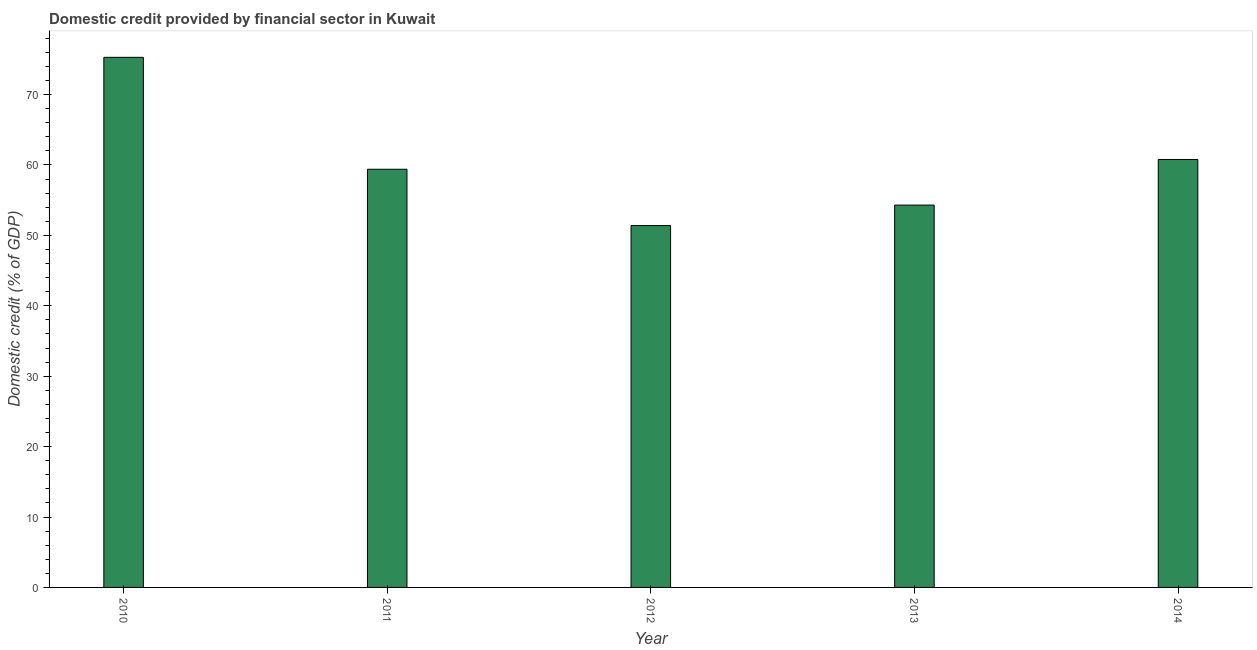What is the title of the graph?
Ensure brevity in your answer.  Domestic credit provided by financial sector in Kuwait. What is the label or title of the Y-axis?
Your answer should be very brief. Domestic credit (% of GDP). What is the domestic credit provided by financial sector in 2011?
Provide a short and direct response. 59.39. Across all years, what is the maximum domestic credit provided by financial sector?
Keep it short and to the point. 75.28. Across all years, what is the minimum domestic credit provided by financial sector?
Your response must be concise. 51.39. In which year was the domestic credit provided by financial sector minimum?
Your answer should be very brief. 2012. What is the sum of the domestic credit provided by financial sector?
Your answer should be very brief. 301.14. What is the difference between the domestic credit provided by financial sector in 2011 and 2012?
Provide a short and direct response. 8. What is the average domestic credit provided by financial sector per year?
Give a very brief answer. 60.23. What is the median domestic credit provided by financial sector?
Give a very brief answer. 59.39. What is the ratio of the domestic credit provided by financial sector in 2013 to that in 2014?
Make the answer very short. 0.89. Is the domestic credit provided by financial sector in 2010 less than that in 2014?
Your answer should be compact. No. Is the difference between the domestic credit provided by financial sector in 2012 and 2014 greater than the difference between any two years?
Provide a succinct answer. No. What is the difference between the highest and the second highest domestic credit provided by financial sector?
Make the answer very short. 14.51. Is the sum of the domestic credit provided by financial sector in 2011 and 2013 greater than the maximum domestic credit provided by financial sector across all years?
Your response must be concise. Yes. What is the difference between the highest and the lowest domestic credit provided by financial sector?
Offer a very short reply. 23.9. In how many years, is the domestic credit provided by financial sector greater than the average domestic credit provided by financial sector taken over all years?
Offer a terse response. 2. What is the Domestic credit (% of GDP) of 2010?
Offer a terse response. 75.28. What is the Domestic credit (% of GDP) of 2011?
Your response must be concise. 59.39. What is the Domestic credit (% of GDP) of 2012?
Keep it short and to the point. 51.39. What is the Domestic credit (% of GDP) of 2013?
Your answer should be compact. 54.3. What is the Domestic credit (% of GDP) of 2014?
Give a very brief answer. 60.78. What is the difference between the Domestic credit (% of GDP) in 2010 and 2011?
Make the answer very short. 15.9. What is the difference between the Domestic credit (% of GDP) in 2010 and 2012?
Your answer should be very brief. 23.9. What is the difference between the Domestic credit (% of GDP) in 2010 and 2013?
Provide a short and direct response. 20.98. What is the difference between the Domestic credit (% of GDP) in 2010 and 2014?
Ensure brevity in your answer.  14.51. What is the difference between the Domestic credit (% of GDP) in 2011 and 2012?
Provide a short and direct response. 8. What is the difference between the Domestic credit (% of GDP) in 2011 and 2013?
Offer a very short reply. 5.09. What is the difference between the Domestic credit (% of GDP) in 2011 and 2014?
Provide a succinct answer. -1.39. What is the difference between the Domestic credit (% of GDP) in 2012 and 2013?
Offer a terse response. -2.91. What is the difference between the Domestic credit (% of GDP) in 2012 and 2014?
Your answer should be very brief. -9.39. What is the difference between the Domestic credit (% of GDP) in 2013 and 2014?
Offer a terse response. -6.48. What is the ratio of the Domestic credit (% of GDP) in 2010 to that in 2011?
Ensure brevity in your answer.  1.27. What is the ratio of the Domestic credit (% of GDP) in 2010 to that in 2012?
Your response must be concise. 1.47. What is the ratio of the Domestic credit (% of GDP) in 2010 to that in 2013?
Ensure brevity in your answer.  1.39. What is the ratio of the Domestic credit (% of GDP) in 2010 to that in 2014?
Your answer should be very brief. 1.24. What is the ratio of the Domestic credit (% of GDP) in 2011 to that in 2012?
Your answer should be very brief. 1.16. What is the ratio of the Domestic credit (% of GDP) in 2011 to that in 2013?
Offer a very short reply. 1.09. What is the ratio of the Domestic credit (% of GDP) in 2012 to that in 2013?
Make the answer very short. 0.95. What is the ratio of the Domestic credit (% of GDP) in 2012 to that in 2014?
Your answer should be compact. 0.85. What is the ratio of the Domestic credit (% of GDP) in 2013 to that in 2014?
Your response must be concise. 0.89. 